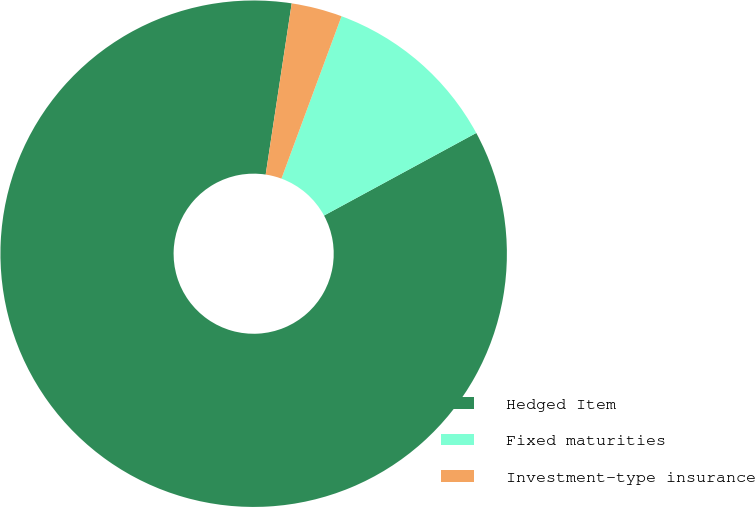Convert chart to OTSL. <chart><loc_0><loc_0><loc_500><loc_500><pie_chart><fcel>Hedged Item<fcel>Fixed maturities<fcel>Investment-type insurance<nl><fcel>85.32%<fcel>11.45%<fcel>3.24%<nl></chart> 